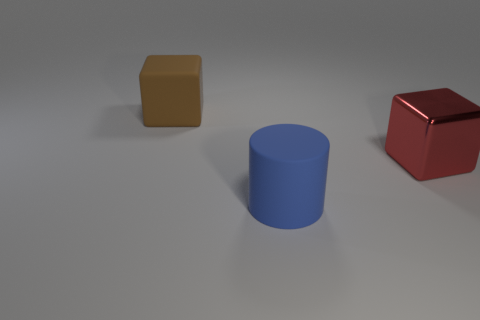Subtract all brown cubes. How many cubes are left? 1 Subtract 1 cubes. How many cubes are left? 1 Subtract all blocks. How many objects are left? 1 Subtract 1 blue cylinders. How many objects are left? 2 Subtract all blue cubes. Subtract all yellow cylinders. How many cubes are left? 2 Subtract all green cubes. How many purple cylinders are left? 0 Subtract all large cyan balls. Subtract all cylinders. How many objects are left? 2 Add 3 blue rubber things. How many blue rubber things are left? 4 Add 1 brown matte objects. How many brown matte objects exist? 2 Add 3 tiny matte cubes. How many objects exist? 6 